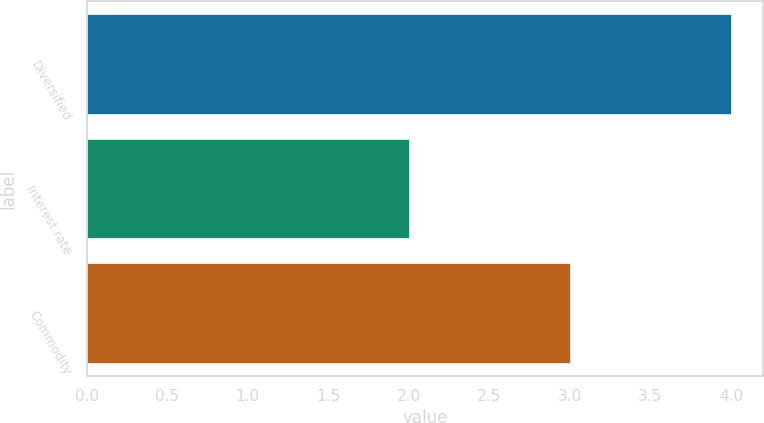Convert chart to OTSL. <chart><loc_0><loc_0><loc_500><loc_500><bar_chart><fcel>Diversified<fcel>Interest rate<fcel>Commodity<nl><fcel>4<fcel>2<fcel>3<nl></chart> 